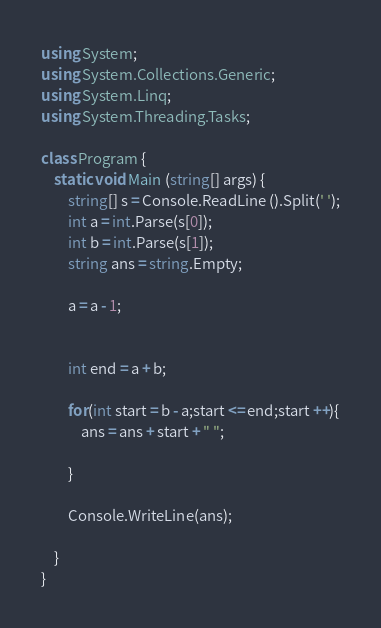Convert code to text. <code><loc_0><loc_0><loc_500><loc_500><_C#_>using System;
using System.Collections.Generic;
using System.Linq;
using System.Threading.Tasks;

class Program {
    static void Main (string[] args) {
        string[] s = Console.ReadLine ().Split(' ');
        int a = int.Parse(s[0]);
        int b = int.Parse(s[1]);
        string ans = string.Empty;

        a = a - 1;

        
        int end = a + b;

        for(int start = b - a;start <= end;start ++){
            ans = ans + start + " ";

        }

        Console.WriteLine(ans);

    }
}</code> 